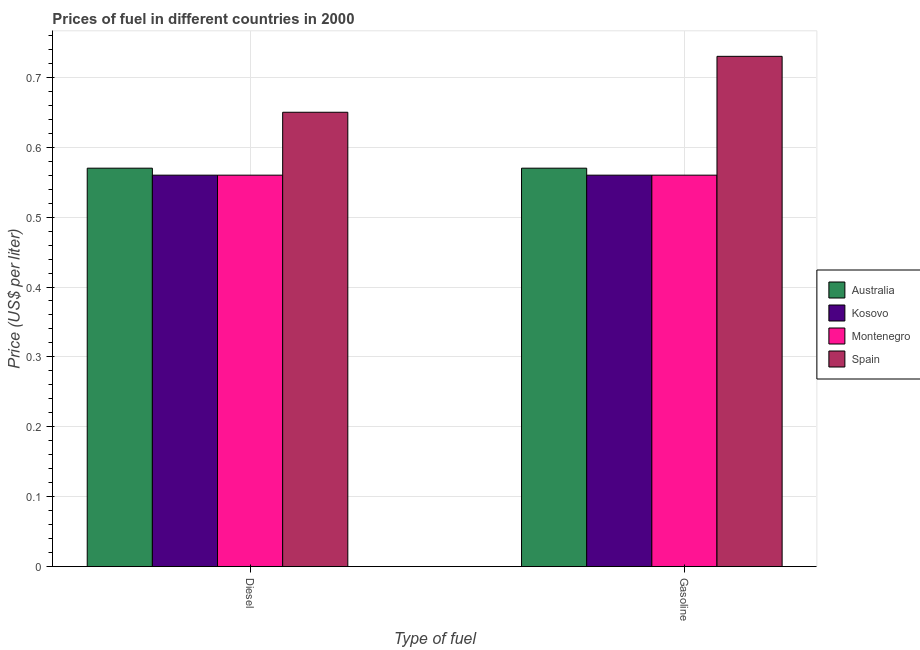How many different coloured bars are there?
Your answer should be very brief. 4. How many groups of bars are there?
Offer a terse response. 2. Are the number of bars on each tick of the X-axis equal?
Ensure brevity in your answer.  Yes. What is the label of the 2nd group of bars from the left?
Give a very brief answer. Gasoline. What is the gasoline price in Spain?
Offer a terse response. 0.73. Across all countries, what is the maximum gasoline price?
Provide a succinct answer. 0.73. Across all countries, what is the minimum diesel price?
Ensure brevity in your answer.  0.56. In which country was the gasoline price maximum?
Keep it short and to the point. Spain. In which country was the gasoline price minimum?
Make the answer very short. Kosovo. What is the total diesel price in the graph?
Give a very brief answer. 2.34. What is the difference between the diesel price in Kosovo and that in Montenegro?
Your answer should be compact. 0. What is the difference between the diesel price in Australia and the gasoline price in Spain?
Ensure brevity in your answer.  -0.16. What is the average gasoline price per country?
Ensure brevity in your answer.  0.6. What is the difference between the gasoline price and diesel price in Spain?
Provide a succinct answer. 0.08. In how many countries, is the diesel price greater than 0.18 US$ per litre?
Your answer should be compact. 4. What is the ratio of the diesel price in Kosovo to that in Spain?
Give a very brief answer. 0.86. Is the gasoline price in Australia less than that in Spain?
Your answer should be compact. Yes. In how many countries, is the diesel price greater than the average diesel price taken over all countries?
Give a very brief answer. 1. What does the 1st bar from the left in Diesel represents?
Provide a short and direct response. Australia. What does the 3rd bar from the right in Gasoline represents?
Give a very brief answer. Kosovo. How many bars are there?
Offer a terse response. 8. Are all the bars in the graph horizontal?
Ensure brevity in your answer.  No. Are the values on the major ticks of Y-axis written in scientific E-notation?
Give a very brief answer. No. Does the graph contain grids?
Your answer should be compact. Yes. What is the title of the graph?
Provide a succinct answer. Prices of fuel in different countries in 2000. What is the label or title of the X-axis?
Ensure brevity in your answer.  Type of fuel. What is the label or title of the Y-axis?
Your answer should be very brief. Price (US$ per liter). What is the Price (US$ per liter) in Australia in Diesel?
Provide a succinct answer. 0.57. What is the Price (US$ per liter) in Kosovo in Diesel?
Provide a succinct answer. 0.56. What is the Price (US$ per liter) of Montenegro in Diesel?
Make the answer very short. 0.56. What is the Price (US$ per liter) of Spain in Diesel?
Offer a very short reply. 0.65. What is the Price (US$ per liter) in Australia in Gasoline?
Keep it short and to the point. 0.57. What is the Price (US$ per liter) of Kosovo in Gasoline?
Your answer should be very brief. 0.56. What is the Price (US$ per liter) in Montenegro in Gasoline?
Provide a short and direct response. 0.56. What is the Price (US$ per liter) in Spain in Gasoline?
Offer a very short reply. 0.73. Across all Type of fuel, what is the maximum Price (US$ per liter) in Australia?
Keep it short and to the point. 0.57. Across all Type of fuel, what is the maximum Price (US$ per liter) of Kosovo?
Offer a terse response. 0.56. Across all Type of fuel, what is the maximum Price (US$ per liter) in Montenegro?
Your answer should be very brief. 0.56. Across all Type of fuel, what is the maximum Price (US$ per liter) in Spain?
Give a very brief answer. 0.73. Across all Type of fuel, what is the minimum Price (US$ per liter) of Australia?
Ensure brevity in your answer.  0.57. Across all Type of fuel, what is the minimum Price (US$ per liter) in Kosovo?
Make the answer very short. 0.56. Across all Type of fuel, what is the minimum Price (US$ per liter) of Montenegro?
Ensure brevity in your answer.  0.56. Across all Type of fuel, what is the minimum Price (US$ per liter) in Spain?
Your response must be concise. 0.65. What is the total Price (US$ per liter) of Australia in the graph?
Offer a very short reply. 1.14. What is the total Price (US$ per liter) of Kosovo in the graph?
Ensure brevity in your answer.  1.12. What is the total Price (US$ per liter) of Montenegro in the graph?
Ensure brevity in your answer.  1.12. What is the total Price (US$ per liter) in Spain in the graph?
Your answer should be compact. 1.38. What is the difference between the Price (US$ per liter) of Kosovo in Diesel and that in Gasoline?
Your answer should be compact. 0. What is the difference between the Price (US$ per liter) in Montenegro in Diesel and that in Gasoline?
Your response must be concise. 0. What is the difference between the Price (US$ per liter) in Spain in Diesel and that in Gasoline?
Your answer should be very brief. -0.08. What is the difference between the Price (US$ per liter) in Australia in Diesel and the Price (US$ per liter) in Kosovo in Gasoline?
Make the answer very short. 0.01. What is the difference between the Price (US$ per liter) of Australia in Diesel and the Price (US$ per liter) of Spain in Gasoline?
Give a very brief answer. -0.16. What is the difference between the Price (US$ per liter) in Kosovo in Diesel and the Price (US$ per liter) in Spain in Gasoline?
Give a very brief answer. -0.17. What is the difference between the Price (US$ per liter) in Montenegro in Diesel and the Price (US$ per liter) in Spain in Gasoline?
Your response must be concise. -0.17. What is the average Price (US$ per liter) in Australia per Type of fuel?
Offer a very short reply. 0.57. What is the average Price (US$ per liter) of Kosovo per Type of fuel?
Your answer should be compact. 0.56. What is the average Price (US$ per liter) in Montenegro per Type of fuel?
Make the answer very short. 0.56. What is the average Price (US$ per liter) of Spain per Type of fuel?
Your answer should be compact. 0.69. What is the difference between the Price (US$ per liter) in Australia and Price (US$ per liter) in Kosovo in Diesel?
Offer a very short reply. 0.01. What is the difference between the Price (US$ per liter) in Australia and Price (US$ per liter) in Montenegro in Diesel?
Your answer should be compact. 0.01. What is the difference between the Price (US$ per liter) of Australia and Price (US$ per liter) of Spain in Diesel?
Offer a very short reply. -0.08. What is the difference between the Price (US$ per liter) in Kosovo and Price (US$ per liter) in Montenegro in Diesel?
Offer a very short reply. 0. What is the difference between the Price (US$ per liter) in Kosovo and Price (US$ per liter) in Spain in Diesel?
Give a very brief answer. -0.09. What is the difference between the Price (US$ per liter) in Montenegro and Price (US$ per liter) in Spain in Diesel?
Your answer should be very brief. -0.09. What is the difference between the Price (US$ per liter) of Australia and Price (US$ per liter) of Kosovo in Gasoline?
Your answer should be compact. 0.01. What is the difference between the Price (US$ per liter) in Australia and Price (US$ per liter) in Spain in Gasoline?
Offer a terse response. -0.16. What is the difference between the Price (US$ per liter) in Kosovo and Price (US$ per liter) in Spain in Gasoline?
Your answer should be very brief. -0.17. What is the difference between the Price (US$ per liter) in Montenegro and Price (US$ per liter) in Spain in Gasoline?
Make the answer very short. -0.17. What is the ratio of the Price (US$ per liter) of Spain in Diesel to that in Gasoline?
Your response must be concise. 0.89. What is the difference between the highest and the second highest Price (US$ per liter) in Australia?
Ensure brevity in your answer.  0. What is the difference between the highest and the second highest Price (US$ per liter) of Kosovo?
Give a very brief answer. 0. What is the difference between the highest and the second highest Price (US$ per liter) in Montenegro?
Make the answer very short. 0. What is the difference between the highest and the second highest Price (US$ per liter) of Spain?
Make the answer very short. 0.08. What is the difference between the highest and the lowest Price (US$ per liter) of Australia?
Offer a very short reply. 0. What is the difference between the highest and the lowest Price (US$ per liter) in Spain?
Keep it short and to the point. 0.08. 